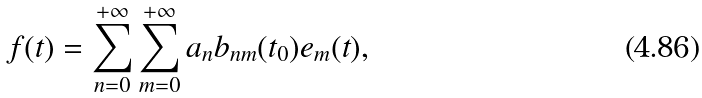Convert formula to latex. <formula><loc_0><loc_0><loc_500><loc_500>f ( t ) = \sum _ { n = 0 } ^ { + \infty } \sum _ { m = 0 } ^ { + \infty } a _ { n } b _ { n m } ( t _ { 0 } ) e _ { m } ( t ) ,</formula> 